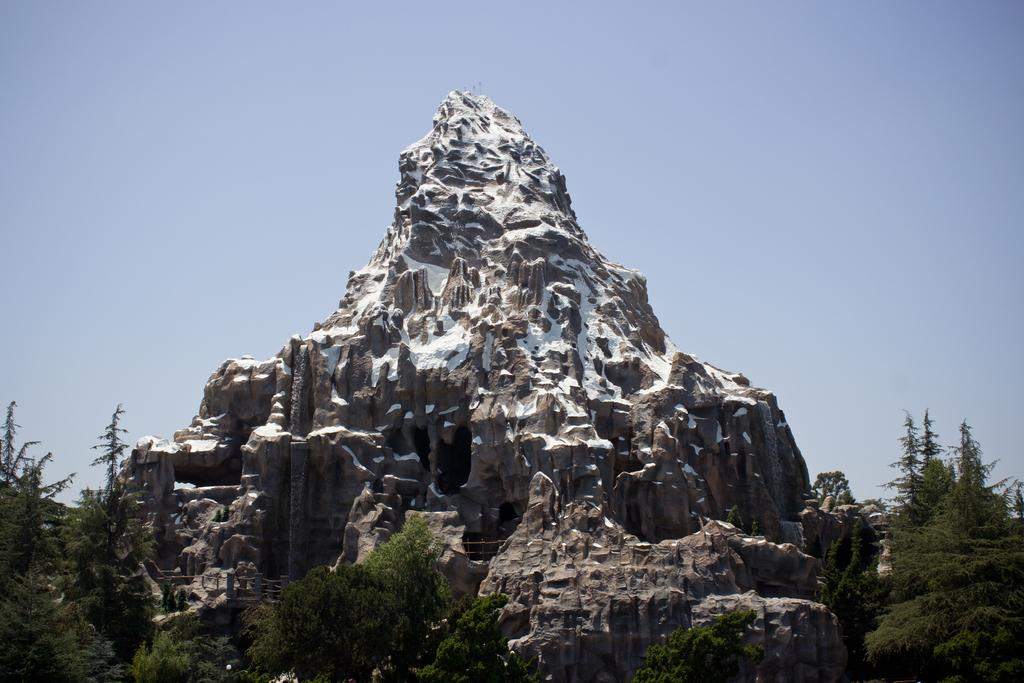What is the main subject in the center of the image? There is a rock in the center of the image. What type of vegetation can be seen at the bottom of the image? There are trees at the bottom of the image. What can be seen in the background of the image? The sky is visible in the background of the image. How many circles can be seen in the image? There are no circles present in the image. What type of unit is used to measure the height of the trees in the image? The facts provided do not mention any units of measurement for the trees. 